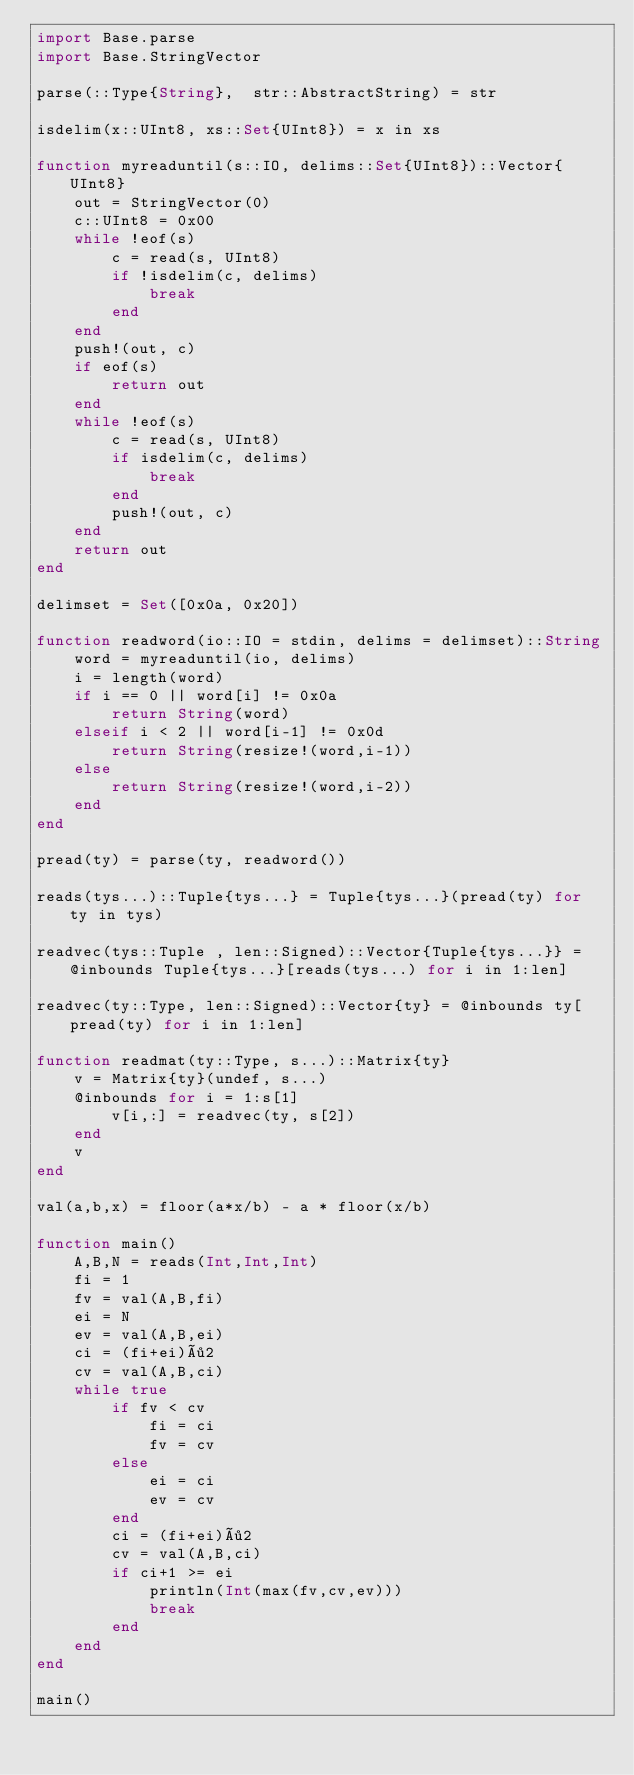Convert code to text. <code><loc_0><loc_0><loc_500><loc_500><_Julia_>import Base.parse
import Base.StringVector

parse(::Type{String},  str::AbstractString) = str

isdelim(x::UInt8, xs::Set{UInt8}) = x in xs

function myreaduntil(s::IO, delims::Set{UInt8})::Vector{UInt8}
    out = StringVector(0)
    c::UInt8 = 0x00
    while !eof(s)
        c = read(s, UInt8)
        if !isdelim(c, delims)
            break
        end
    end
    push!(out, c)
    if eof(s)
        return out
    end
    while !eof(s)
        c = read(s, UInt8)
        if isdelim(c, delims)
            break
        end
        push!(out, c)
    end
    return out
end

delimset = Set([0x0a, 0x20])

function readword(io::IO = stdin, delims = delimset)::String
    word = myreaduntil(io, delims)
    i = length(word)
    if i == 0 || word[i] != 0x0a
        return String(word)
    elseif i < 2 || word[i-1] != 0x0d
        return String(resize!(word,i-1))
    else
        return String(resize!(word,i-2))
    end
end

pread(ty) = parse(ty, readword())

reads(tys...)::Tuple{tys...} = Tuple{tys...}(pread(ty) for ty in tys)

readvec(tys::Tuple , len::Signed)::Vector{Tuple{tys...}} = @inbounds Tuple{tys...}[reads(tys...) for i in 1:len]

readvec(ty::Type, len::Signed)::Vector{ty} = @inbounds ty[pread(ty) for i in 1:len]

function readmat(ty::Type, s...)::Matrix{ty}
    v = Matrix{ty}(undef, s...)
    @inbounds for i = 1:s[1]
        v[i,:] = readvec(ty, s[2])
    end
    v
end

val(a,b,x) = floor(a*x/b) - a * floor(x/b)

function main()
    A,B,N = reads(Int,Int,Int)
    fi = 1
    fv = val(A,B,fi)
    ei = N
    ev = val(A,B,ei)
    ci = (fi+ei)÷2
    cv = val(A,B,ci)
    while true
        if fv < cv
            fi = ci
            fv = cv
        else
            ei = ci
            ev = cv
        end
        ci = (fi+ei)÷2
        cv = val(A,B,ci)
        if ci+1 >= ei
            println(Int(max(fv,cv,ev)))
            break
        end
    end
end

main()
</code> 